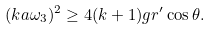<formula> <loc_0><loc_0><loc_500><loc_500>( k a \omega _ { 3 } ) ^ { 2 } \geq 4 ( k + 1 ) g r ^ { \prime } \cos \theta .</formula> 